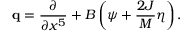<formula> <loc_0><loc_0><loc_500><loc_500>{ q } = { \frac { \partial } { \partial x ^ { 5 } } } + B \left ( \psi + { \frac { 2 J } { M } } \eta \right ) .</formula> 